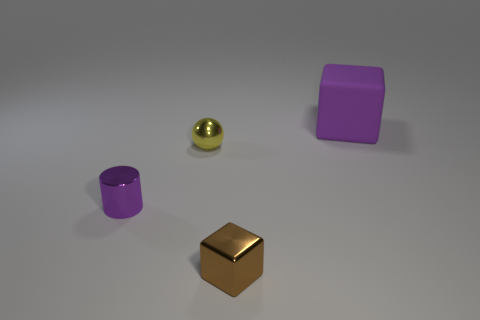Add 3 purple shiny cubes. How many objects exist? 7 Subtract all spheres. How many objects are left? 3 Subtract 0 blue balls. How many objects are left? 4 Subtract all big blocks. Subtract all tiny things. How many objects are left? 0 Add 4 purple rubber cubes. How many purple rubber cubes are left? 5 Add 3 brown shiny cubes. How many brown shiny cubes exist? 4 